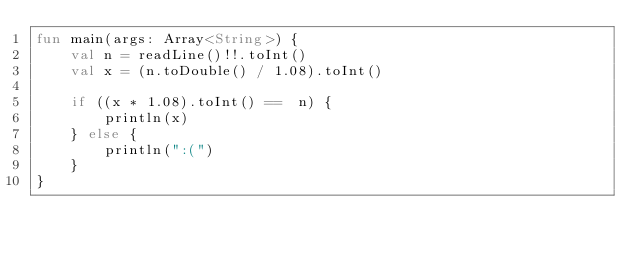<code> <loc_0><loc_0><loc_500><loc_500><_Kotlin_>fun main(args: Array<String>) {
    val n = readLine()!!.toInt()
    val x = (n.toDouble() / 1.08).toInt()

    if ((x * 1.08).toInt() ==  n) {
        println(x)
    } else {
        println(":(")
    }
}</code> 